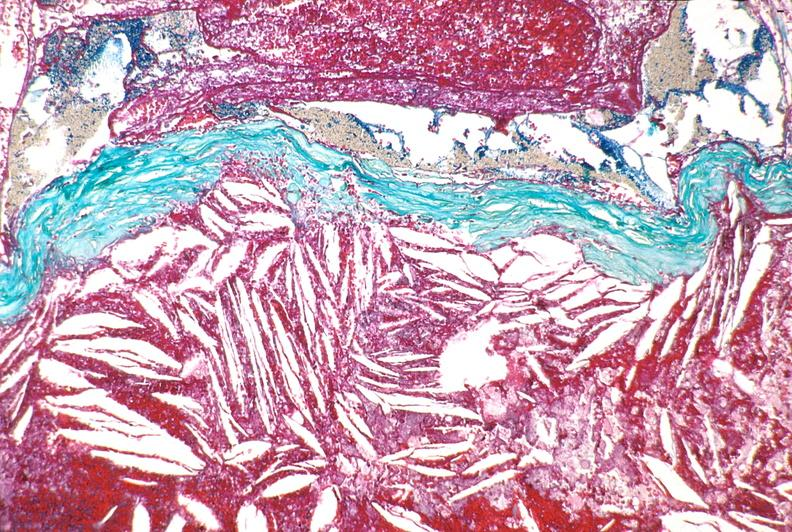s vasculature present?
Answer the question using a single word or phrase. Yes 